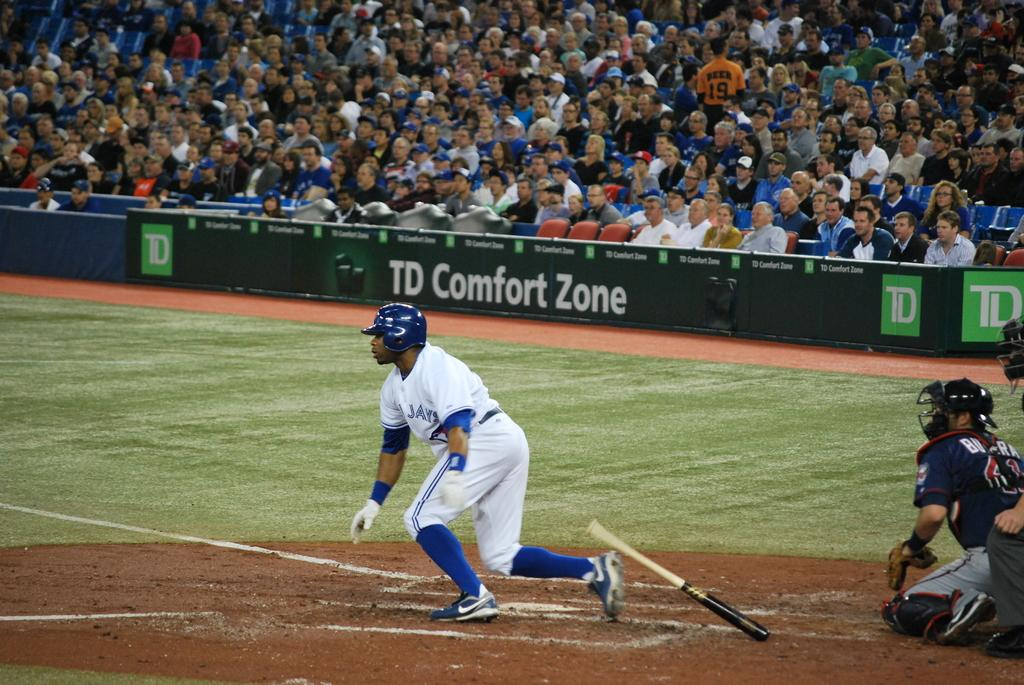Provide a one-sentence caption for the provided image. one of the sponsors of the game is TD Comfort Zone. 